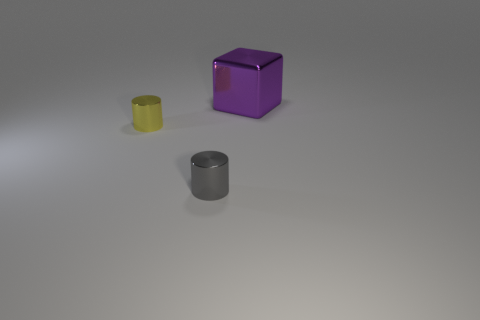Is there anything else that is the same size as the purple block?
Offer a terse response. No. Are any big gray metallic spheres visible?
Your answer should be compact. No. How many other objects are the same size as the yellow object?
Offer a terse response. 1. How many things are cyan rubber objects or large blocks?
Provide a succinct answer. 1. The small shiny object behind the tiny cylinder that is to the right of the yellow object is what shape?
Provide a succinct answer. Cylinder. The object that is both in front of the cube and on the right side of the yellow shiny object has what shape?
Keep it short and to the point. Cylinder. How many things are either blocks or objects that are behind the yellow metallic thing?
Your answer should be compact. 1. There is another tiny object that is the same shape as the tiny gray object; what is its material?
Your response must be concise. Metal. The thing that is in front of the large metallic thing and on the right side of the tiny yellow shiny thing is made of what material?
Offer a very short reply. Metal. What number of yellow metallic objects are the same shape as the gray metal object?
Make the answer very short. 1. 